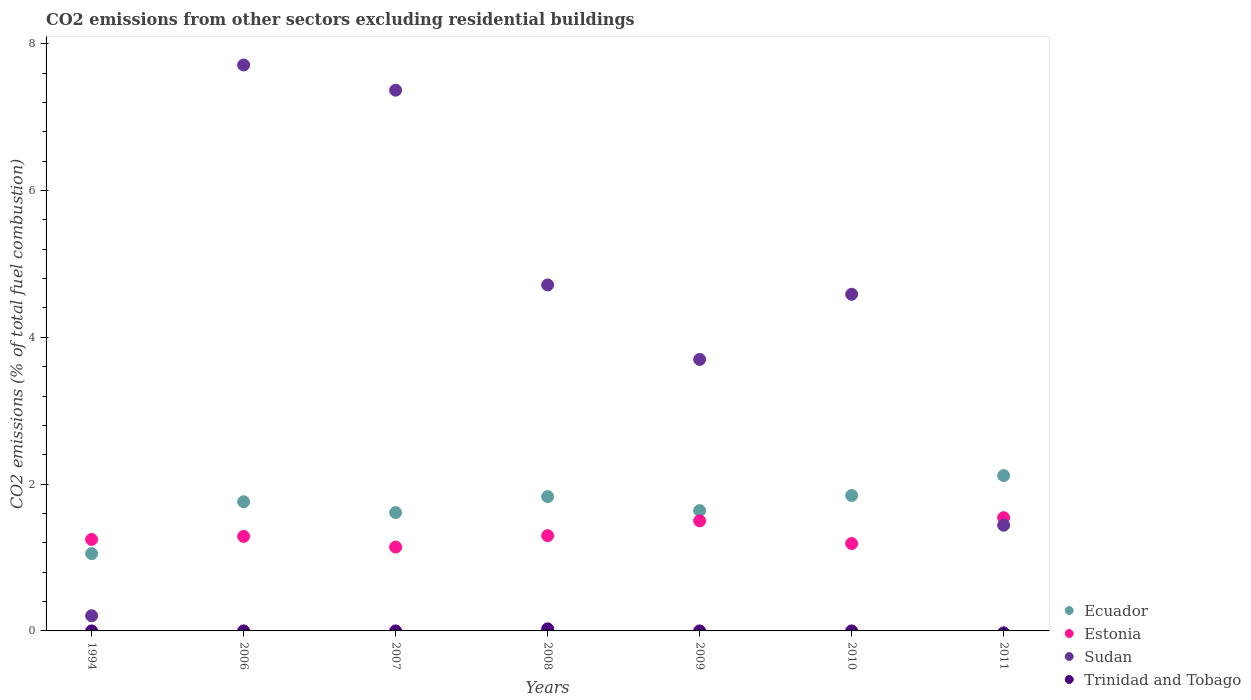How many different coloured dotlines are there?
Give a very brief answer. 4. What is the total CO2 emitted in Ecuador in 2011?
Ensure brevity in your answer.  2.12. Across all years, what is the maximum total CO2 emitted in Sudan?
Your response must be concise. 7.71. In which year was the total CO2 emitted in Estonia maximum?
Provide a succinct answer. 2011. What is the total total CO2 emitted in Ecuador in the graph?
Provide a short and direct response. 11.86. What is the difference between the total CO2 emitted in Estonia in 2007 and that in 2010?
Your answer should be compact. -0.05. What is the difference between the total CO2 emitted in Ecuador in 2006 and the total CO2 emitted in Sudan in 2011?
Your answer should be very brief. 0.32. What is the average total CO2 emitted in Trinidad and Tobago per year?
Your answer should be compact. 0. In the year 2009, what is the difference between the total CO2 emitted in Ecuador and total CO2 emitted in Estonia?
Provide a short and direct response. 0.14. In how many years, is the total CO2 emitted in Estonia greater than 5.2?
Make the answer very short. 0. What is the ratio of the total CO2 emitted in Sudan in 2006 to that in 2008?
Keep it short and to the point. 1.64. Is the difference between the total CO2 emitted in Ecuador in 1994 and 2008 greater than the difference between the total CO2 emitted in Estonia in 1994 and 2008?
Offer a terse response. No. What is the difference between the highest and the second highest total CO2 emitted in Estonia?
Ensure brevity in your answer.  0.04. What is the difference between the highest and the lowest total CO2 emitted in Trinidad and Tobago?
Ensure brevity in your answer.  0.03. Does the total CO2 emitted in Trinidad and Tobago monotonically increase over the years?
Give a very brief answer. No. Are the values on the major ticks of Y-axis written in scientific E-notation?
Ensure brevity in your answer.  No. Does the graph contain any zero values?
Keep it short and to the point. Yes. Does the graph contain grids?
Offer a terse response. No. How are the legend labels stacked?
Offer a terse response. Vertical. What is the title of the graph?
Give a very brief answer. CO2 emissions from other sectors excluding residential buildings. What is the label or title of the X-axis?
Your response must be concise. Years. What is the label or title of the Y-axis?
Provide a succinct answer. CO2 emissions (% of total fuel combustion). What is the CO2 emissions (% of total fuel combustion) of Ecuador in 1994?
Offer a terse response. 1.05. What is the CO2 emissions (% of total fuel combustion) in Estonia in 1994?
Provide a short and direct response. 1.25. What is the CO2 emissions (% of total fuel combustion) of Sudan in 1994?
Provide a short and direct response. 0.21. What is the CO2 emissions (% of total fuel combustion) in Trinidad and Tobago in 1994?
Give a very brief answer. 0. What is the CO2 emissions (% of total fuel combustion) in Ecuador in 2006?
Keep it short and to the point. 1.76. What is the CO2 emissions (% of total fuel combustion) in Estonia in 2006?
Offer a very short reply. 1.29. What is the CO2 emissions (% of total fuel combustion) in Sudan in 2006?
Provide a succinct answer. 7.71. What is the CO2 emissions (% of total fuel combustion) in Trinidad and Tobago in 2006?
Your answer should be very brief. 5.05750284541343e-17. What is the CO2 emissions (% of total fuel combustion) in Ecuador in 2007?
Your answer should be compact. 1.61. What is the CO2 emissions (% of total fuel combustion) in Estonia in 2007?
Ensure brevity in your answer.  1.14. What is the CO2 emissions (% of total fuel combustion) of Sudan in 2007?
Keep it short and to the point. 7.37. What is the CO2 emissions (% of total fuel combustion) of Trinidad and Tobago in 2007?
Keep it short and to the point. 4.75396951487204e-17. What is the CO2 emissions (% of total fuel combustion) of Ecuador in 2008?
Offer a very short reply. 1.83. What is the CO2 emissions (% of total fuel combustion) of Estonia in 2008?
Your answer should be very brief. 1.3. What is the CO2 emissions (% of total fuel combustion) in Sudan in 2008?
Provide a succinct answer. 4.71. What is the CO2 emissions (% of total fuel combustion) of Trinidad and Tobago in 2008?
Provide a short and direct response. 0.03. What is the CO2 emissions (% of total fuel combustion) of Ecuador in 2009?
Your answer should be very brief. 1.64. What is the CO2 emissions (% of total fuel combustion) of Estonia in 2009?
Make the answer very short. 1.5. What is the CO2 emissions (% of total fuel combustion) in Sudan in 2009?
Offer a very short reply. 3.7. What is the CO2 emissions (% of total fuel combustion) of Trinidad and Tobago in 2009?
Give a very brief answer. 0. What is the CO2 emissions (% of total fuel combustion) of Ecuador in 2010?
Offer a terse response. 1.85. What is the CO2 emissions (% of total fuel combustion) in Estonia in 2010?
Your answer should be compact. 1.19. What is the CO2 emissions (% of total fuel combustion) in Sudan in 2010?
Make the answer very short. 4.59. What is the CO2 emissions (% of total fuel combustion) in Ecuador in 2011?
Provide a short and direct response. 2.12. What is the CO2 emissions (% of total fuel combustion) of Estonia in 2011?
Your response must be concise. 1.54. What is the CO2 emissions (% of total fuel combustion) of Sudan in 2011?
Ensure brevity in your answer.  1.44. Across all years, what is the maximum CO2 emissions (% of total fuel combustion) of Ecuador?
Provide a short and direct response. 2.12. Across all years, what is the maximum CO2 emissions (% of total fuel combustion) in Estonia?
Your answer should be compact. 1.54. Across all years, what is the maximum CO2 emissions (% of total fuel combustion) of Sudan?
Make the answer very short. 7.71. Across all years, what is the maximum CO2 emissions (% of total fuel combustion) of Trinidad and Tobago?
Offer a very short reply. 0.03. Across all years, what is the minimum CO2 emissions (% of total fuel combustion) of Ecuador?
Your answer should be compact. 1.05. Across all years, what is the minimum CO2 emissions (% of total fuel combustion) in Estonia?
Your answer should be compact. 1.14. Across all years, what is the minimum CO2 emissions (% of total fuel combustion) of Sudan?
Ensure brevity in your answer.  0.21. Across all years, what is the minimum CO2 emissions (% of total fuel combustion) in Trinidad and Tobago?
Ensure brevity in your answer.  0. What is the total CO2 emissions (% of total fuel combustion) of Ecuador in the graph?
Offer a terse response. 11.86. What is the total CO2 emissions (% of total fuel combustion) of Estonia in the graph?
Your response must be concise. 9.21. What is the total CO2 emissions (% of total fuel combustion) in Sudan in the graph?
Provide a succinct answer. 29.72. What is the total CO2 emissions (% of total fuel combustion) in Trinidad and Tobago in the graph?
Offer a terse response. 0.03. What is the difference between the CO2 emissions (% of total fuel combustion) in Ecuador in 1994 and that in 2006?
Your answer should be compact. -0.71. What is the difference between the CO2 emissions (% of total fuel combustion) of Estonia in 1994 and that in 2006?
Keep it short and to the point. -0.04. What is the difference between the CO2 emissions (% of total fuel combustion) in Sudan in 1994 and that in 2006?
Offer a terse response. -7.5. What is the difference between the CO2 emissions (% of total fuel combustion) in Ecuador in 1994 and that in 2007?
Your response must be concise. -0.56. What is the difference between the CO2 emissions (% of total fuel combustion) of Estonia in 1994 and that in 2007?
Give a very brief answer. 0.1. What is the difference between the CO2 emissions (% of total fuel combustion) of Sudan in 1994 and that in 2007?
Your answer should be very brief. -7.16. What is the difference between the CO2 emissions (% of total fuel combustion) of Ecuador in 1994 and that in 2008?
Give a very brief answer. -0.78. What is the difference between the CO2 emissions (% of total fuel combustion) of Estonia in 1994 and that in 2008?
Provide a succinct answer. -0.05. What is the difference between the CO2 emissions (% of total fuel combustion) of Sudan in 1994 and that in 2008?
Give a very brief answer. -4.51. What is the difference between the CO2 emissions (% of total fuel combustion) of Ecuador in 1994 and that in 2009?
Ensure brevity in your answer.  -0.59. What is the difference between the CO2 emissions (% of total fuel combustion) of Estonia in 1994 and that in 2009?
Offer a terse response. -0.25. What is the difference between the CO2 emissions (% of total fuel combustion) of Sudan in 1994 and that in 2009?
Provide a short and direct response. -3.49. What is the difference between the CO2 emissions (% of total fuel combustion) of Ecuador in 1994 and that in 2010?
Make the answer very short. -0.79. What is the difference between the CO2 emissions (% of total fuel combustion) of Estonia in 1994 and that in 2010?
Provide a short and direct response. 0.06. What is the difference between the CO2 emissions (% of total fuel combustion) of Sudan in 1994 and that in 2010?
Make the answer very short. -4.38. What is the difference between the CO2 emissions (% of total fuel combustion) of Ecuador in 1994 and that in 2011?
Keep it short and to the point. -1.06. What is the difference between the CO2 emissions (% of total fuel combustion) in Estonia in 1994 and that in 2011?
Your answer should be compact. -0.3. What is the difference between the CO2 emissions (% of total fuel combustion) in Sudan in 1994 and that in 2011?
Provide a succinct answer. -1.23. What is the difference between the CO2 emissions (% of total fuel combustion) of Ecuador in 2006 and that in 2007?
Make the answer very short. 0.15. What is the difference between the CO2 emissions (% of total fuel combustion) in Estonia in 2006 and that in 2007?
Keep it short and to the point. 0.15. What is the difference between the CO2 emissions (% of total fuel combustion) of Sudan in 2006 and that in 2007?
Make the answer very short. 0.34. What is the difference between the CO2 emissions (% of total fuel combustion) of Ecuador in 2006 and that in 2008?
Offer a terse response. -0.07. What is the difference between the CO2 emissions (% of total fuel combustion) of Estonia in 2006 and that in 2008?
Your response must be concise. -0.01. What is the difference between the CO2 emissions (% of total fuel combustion) of Sudan in 2006 and that in 2008?
Your answer should be compact. 3. What is the difference between the CO2 emissions (% of total fuel combustion) of Trinidad and Tobago in 2006 and that in 2008?
Your answer should be very brief. -0.03. What is the difference between the CO2 emissions (% of total fuel combustion) of Ecuador in 2006 and that in 2009?
Keep it short and to the point. 0.12. What is the difference between the CO2 emissions (% of total fuel combustion) of Estonia in 2006 and that in 2009?
Your response must be concise. -0.21. What is the difference between the CO2 emissions (% of total fuel combustion) of Sudan in 2006 and that in 2009?
Provide a succinct answer. 4.01. What is the difference between the CO2 emissions (% of total fuel combustion) of Ecuador in 2006 and that in 2010?
Offer a terse response. -0.09. What is the difference between the CO2 emissions (% of total fuel combustion) in Estonia in 2006 and that in 2010?
Offer a terse response. 0.1. What is the difference between the CO2 emissions (% of total fuel combustion) in Sudan in 2006 and that in 2010?
Keep it short and to the point. 3.12. What is the difference between the CO2 emissions (% of total fuel combustion) of Ecuador in 2006 and that in 2011?
Keep it short and to the point. -0.36. What is the difference between the CO2 emissions (% of total fuel combustion) of Estonia in 2006 and that in 2011?
Make the answer very short. -0.26. What is the difference between the CO2 emissions (% of total fuel combustion) of Sudan in 2006 and that in 2011?
Offer a very short reply. 6.27. What is the difference between the CO2 emissions (% of total fuel combustion) in Ecuador in 2007 and that in 2008?
Your response must be concise. -0.22. What is the difference between the CO2 emissions (% of total fuel combustion) of Estonia in 2007 and that in 2008?
Your answer should be very brief. -0.16. What is the difference between the CO2 emissions (% of total fuel combustion) in Sudan in 2007 and that in 2008?
Ensure brevity in your answer.  2.65. What is the difference between the CO2 emissions (% of total fuel combustion) in Trinidad and Tobago in 2007 and that in 2008?
Offer a terse response. -0.03. What is the difference between the CO2 emissions (% of total fuel combustion) of Ecuador in 2007 and that in 2009?
Offer a very short reply. -0.03. What is the difference between the CO2 emissions (% of total fuel combustion) of Estonia in 2007 and that in 2009?
Your response must be concise. -0.36. What is the difference between the CO2 emissions (% of total fuel combustion) of Sudan in 2007 and that in 2009?
Ensure brevity in your answer.  3.67. What is the difference between the CO2 emissions (% of total fuel combustion) of Ecuador in 2007 and that in 2010?
Offer a terse response. -0.23. What is the difference between the CO2 emissions (% of total fuel combustion) in Estonia in 2007 and that in 2010?
Provide a succinct answer. -0.05. What is the difference between the CO2 emissions (% of total fuel combustion) of Sudan in 2007 and that in 2010?
Provide a succinct answer. 2.78. What is the difference between the CO2 emissions (% of total fuel combustion) in Ecuador in 2007 and that in 2011?
Make the answer very short. -0.5. What is the difference between the CO2 emissions (% of total fuel combustion) in Estonia in 2007 and that in 2011?
Your answer should be very brief. -0.4. What is the difference between the CO2 emissions (% of total fuel combustion) in Sudan in 2007 and that in 2011?
Keep it short and to the point. 5.93. What is the difference between the CO2 emissions (% of total fuel combustion) in Ecuador in 2008 and that in 2009?
Provide a short and direct response. 0.19. What is the difference between the CO2 emissions (% of total fuel combustion) in Estonia in 2008 and that in 2009?
Make the answer very short. -0.2. What is the difference between the CO2 emissions (% of total fuel combustion) of Sudan in 2008 and that in 2009?
Keep it short and to the point. 1.01. What is the difference between the CO2 emissions (% of total fuel combustion) of Ecuador in 2008 and that in 2010?
Provide a succinct answer. -0.02. What is the difference between the CO2 emissions (% of total fuel combustion) in Estonia in 2008 and that in 2010?
Your answer should be very brief. 0.11. What is the difference between the CO2 emissions (% of total fuel combustion) of Sudan in 2008 and that in 2010?
Your answer should be compact. 0.13. What is the difference between the CO2 emissions (% of total fuel combustion) of Ecuador in 2008 and that in 2011?
Offer a terse response. -0.29. What is the difference between the CO2 emissions (% of total fuel combustion) of Estonia in 2008 and that in 2011?
Give a very brief answer. -0.24. What is the difference between the CO2 emissions (% of total fuel combustion) of Sudan in 2008 and that in 2011?
Ensure brevity in your answer.  3.27. What is the difference between the CO2 emissions (% of total fuel combustion) of Ecuador in 2009 and that in 2010?
Give a very brief answer. -0.21. What is the difference between the CO2 emissions (% of total fuel combustion) in Estonia in 2009 and that in 2010?
Provide a succinct answer. 0.31. What is the difference between the CO2 emissions (% of total fuel combustion) in Sudan in 2009 and that in 2010?
Give a very brief answer. -0.89. What is the difference between the CO2 emissions (% of total fuel combustion) in Ecuador in 2009 and that in 2011?
Your answer should be compact. -0.48. What is the difference between the CO2 emissions (% of total fuel combustion) in Estonia in 2009 and that in 2011?
Make the answer very short. -0.04. What is the difference between the CO2 emissions (% of total fuel combustion) of Sudan in 2009 and that in 2011?
Provide a succinct answer. 2.26. What is the difference between the CO2 emissions (% of total fuel combustion) of Ecuador in 2010 and that in 2011?
Your answer should be very brief. -0.27. What is the difference between the CO2 emissions (% of total fuel combustion) in Estonia in 2010 and that in 2011?
Ensure brevity in your answer.  -0.35. What is the difference between the CO2 emissions (% of total fuel combustion) of Sudan in 2010 and that in 2011?
Provide a short and direct response. 3.15. What is the difference between the CO2 emissions (% of total fuel combustion) in Ecuador in 1994 and the CO2 emissions (% of total fuel combustion) in Estonia in 2006?
Your response must be concise. -0.23. What is the difference between the CO2 emissions (% of total fuel combustion) of Ecuador in 1994 and the CO2 emissions (% of total fuel combustion) of Sudan in 2006?
Provide a succinct answer. -6.66. What is the difference between the CO2 emissions (% of total fuel combustion) in Ecuador in 1994 and the CO2 emissions (% of total fuel combustion) in Trinidad and Tobago in 2006?
Your answer should be very brief. 1.05. What is the difference between the CO2 emissions (% of total fuel combustion) of Estonia in 1994 and the CO2 emissions (% of total fuel combustion) of Sudan in 2006?
Make the answer very short. -6.46. What is the difference between the CO2 emissions (% of total fuel combustion) in Estonia in 1994 and the CO2 emissions (% of total fuel combustion) in Trinidad and Tobago in 2006?
Ensure brevity in your answer.  1.25. What is the difference between the CO2 emissions (% of total fuel combustion) in Sudan in 1994 and the CO2 emissions (% of total fuel combustion) in Trinidad and Tobago in 2006?
Your answer should be very brief. 0.21. What is the difference between the CO2 emissions (% of total fuel combustion) of Ecuador in 1994 and the CO2 emissions (% of total fuel combustion) of Estonia in 2007?
Ensure brevity in your answer.  -0.09. What is the difference between the CO2 emissions (% of total fuel combustion) in Ecuador in 1994 and the CO2 emissions (% of total fuel combustion) in Sudan in 2007?
Keep it short and to the point. -6.31. What is the difference between the CO2 emissions (% of total fuel combustion) of Ecuador in 1994 and the CO2 emissions (% of total fuel combustion) of Trinidad and Tobago in 2007?
Ensure brevity in your answer.  1.05. What is the difference between the CO2 emissions (% of total fuel combustion) of Estonia in 1994 and the CO2 emissions (% of total fuel combustion) of Sudan in 2007?
Offer a terse response. -6.12. What is the difference between the CO2 emissions (% of total fuel combustion) in Estonia in 1994 and the CO2 emissions (% of total fuel combustion) in Trinidad and Tobago in 2007?
Your answer should be very brief. 1.25. What is the difference between the CO2 emissions (% of total fuel combustion) of Sudan in 1994 and the CO2 emissions (% of total fuel combustion) of Trinidad and Tobago in 2007?
Provide a short and direct response. 0.21. What is the difference between the CO2 emissions (% of total fuel combustion) of Ecuador in 1994 and the CO2 emissions (% of total fuel combustion) of Estonia in 2008?
Ensure brevity in your answer.  -0.24. What is the difference between the CO2 emissions (% of total fuel combustion) in Ecuador in 1994 and the CO2 emissions (% of total fuel combustion) in Sudan in 2008?
Your answer should be very brief. -3.66. What is the difference between the CO2 emissions (% of total fuel combustion) in Ecuador in 1994 and the CO2 emissions (% of total fuel combustion) in Trinidad and Tobago in 2008?
Ensure brevity in your answer.  1.03. What is the difference between the CO2 emissions (% of total fuel combustion) in Estonia in 1994 and the CO2 emissions (% of total fuel combustion) in Sudan in 2008?
Provide a short and direct response. -3.47. What is the difference between the CO2 emissions (% of total fuel combustion) of Estonia in 1994 and the CO2 emissions (% of total fuel combustion) of Trinidad and Tobago in 2008?
Make the answer very short. 1.22. What is the difference between the CO2 emissions (% of total fuel combustion) of Sudan in 1994 and the CO2 emissions (% of total fuel combustion) of Trinidad and Tobago in 2008?
Your answer should be very brief. 0.18. What is the difference between the CO2 emissions (% of total fuel combustion) of Ecuador in 1994 and the CO2 emissions (% of total fuel combustion) of Estonia in 2009?
Your answer should be very brief. -0.45. What is the difference between the CO2 emissions (% of total fuel combustion) of Ecuador in 1994 and the CO2 emissions (% of total fuel combustion) of Sudan in 2009?
Make the answer very short. -2.65. What is the difference between the CO2 emissions (% of total fuel combustion) in Estonia in 1994 and the CO2 emissions (% of total fuel combustion) in Sudan in 2009?
Give a very brief answer. -2.45. What is the difference between the CO2 emissions (% of total fuel combustion) of Ecuador in 1994 and the CO2 emissions (% of total fuel combustion) of Estonia in 2010?
Your answer should be very brief. -0.14. What is the difference between the CO2 emissions (% of total fuel combustion) of Ecuador in 1994 and the CO2 emissions (% of total fuel combustion) of Sudan in 2010?
Provide a short and direct response. -3.53. What is the difference between the CO2 emissions (% of total fuel combustion) of Estonia in 1994 and the CO2 emissions (% of total fuel combustion) of Sudan in 2010?
Offer a terse response. -3.34. What is the difference between the CO2 emissions (% of total fuel combustion) in Ecuador in 1994 and the CO2 emissions (% of total fuel combustion) in Estonia in 2011?
Offer a very short reply. -0.49. What is the difference between the CO2 emissions (% of total fuel combustion) of Ecuador in 1994 and the CO2 emissions (% of total fuel combustion) of Sudan in 2011?
Ensure brevity in your answer.  -0.39. What is the difference between the CO2 emissions (% of total fuel combustion) in Estonia in 1994 and the CO2 emissions (% of total fuel combustion) in Sudan in 2011?
Provide a succinct answer. -0.19. What is the difference between the CO2 emissions (% of total fuel combustion) in Ecuador in 2006 and the CO2 emissions (% of total fuel combustion) in Estonia in 2007?
Give a very brief answer. 0.62. What is the difference between the CO2 emissions (% of total fuel combustion) of Ecuador in 2006 and the CO2 emissions (% of total fuel combustion) of Sudan in 2007?
Ensure brevity in your answer.  -5.61. What is the difference between the CO2 emissions (% of total fuel combustion) in Ecuador in 2006 and the CO2 emissions (% of total fuel combustion) in Trinidad and Tobago in 2007?
Your response must be concise. 1.76. What is the difference between the CO2 emissions (% of total fuel combustion) in Estonia in 2006 and the CO2 emissions (% of total fuel combustion) in Sudan in 2007?
Your response must be concise. -6.08. What is the difference between the CO2 emissions (% of total fuel combustion) of Estonia in 2006 and the CO2 emissions (% of total fuel combustion) of Trinidad and Tobago in 2007?
Your answer should be very brief. 1.29. What is the difference between the CO2 emissions (% of total fuel combustion) in Sudan in 2006 and the CO2 emissions (% of total fuel combustion) in Trinidad and Tobago in 2007?
Your response must be concise. 7.71. What is the difference between the CO2 emissions (% of total fuel combustion) in Ecuador in 2006 and the CO2 emissions (% of total fuel combustion) in Estonia in 2008?
Ensure brevity in your answer.  0.46. What is the difference between the CO2 emissions (% of total fuel combustion) of Ecuador in 2006 and the CO2 emissions (% of total fuel combustion) of Sudan in 2008?
Offer a very short reply. -2.95. What is the difference between the CO2 emissions (% of total fuel combustion) of Ecuador in 2006 and the CO2 emissions (% of total fuel combustion) of Trinidad and Tobago in 2008?
Provide a succinct answer. 1.73. What is the difference between the CO2 emissions (% of total fuel combustion) in Estonia in 2006 and the CO2 emissions (% of total fuel combustion) in Sudan in 2008?
Provide a short and direct response. -3.43. What is the difference between the CO2 emissions (% of total fuel combustion) in Estonia in 2006 and the CO2 emissions (% of total fuel combustion) in Trinidad and Tobago in 2008?
Your response must be concise. 1.26. What is the difference between the CO2 emissions (% of total fuel combustion) in Sudan in 2006 and the CO2 emissions (% of total fuel combustion) in Trinidad and Tobago in 2008?
Your response must be concise. 7.68. What is the difference between the CO2 emissions (% of total fuel combustion) in Ecuador in 2006 and the CO2 emissions (% of total fuel combustion) in Estonia in 2009?
Provide a succinct answer. 0.26. What is the difference between the CO2 emissions (% of total fuel combustion) of Ecuador in 2006 and the CO2 emissions (% of total fuel combustion) of Sudan in 2009?
Keep it short and to the point. -1.94. What is the difference between the CO2 emissions (% of total fuel combustion) of Estonia in 2006 and the CO2 emissions (% of total fuel combustion) of Sudan in 2009?
Your response must be concise. -2.41. What is the difference between the CO2 emissions (% of total fuel combustion) in Ecuador in 2006 and the CO2 emissions (% of total fuel combustion) in Estonia in 2010?
Make the answer very short. 0.57. What is the difference between the CO2 emissions (% of total fuel combustion) of Ecuador in 2006 and the CO2 emissions (% of total fuel combustion) of Sudan in 2010?
Your answer should be compact. -2.83. What is the difference between the CO2 emissions (% of total fuel combustion) in Estonia in 2006 and the CO2 emissions (% of total fuel combustion) in Sudan in 2010?
Provide a succinct answer. -3.3. What is the difference between the CO2 emissions (% of total fuel combustion) of Ecuador in 2006 and the CO2 emissions (% of total fuel combustion) of Estonia in 2011?
Your answer should be very brief. 0.22. What is the difference between the CO2 emissions (% of total fuel combustion) of Ecuador in 2006 and the CO2 emissions (% of total fuel combustion) of Sudan in 2011?
Your answer should be very brief. 0.32. What is the difference between the CO2 emissions (% of total fuel combustion) of Estonia in 2006 and the CO2 emissions (% of total fuel combustion) of Sudan in 2011?
Offer a terse response. -0.15. What is the difference between the CO2 emissions (% of total fuel combustion) in Ecuador in 2007 and the CO2 emissions (% of total fuel combustion) in Estonia in 2008?
Provide a short and direct response. 0.31. What is the difference between the CO2 emissions (% of total fuel combustion) in Ecuador in 2007 and the CO2 emissions (% of total fuel combustion) in Sudan in 2008?
Give a very brief answer. -3.1. What is the difference between the CO2 emissions (% of total fuel combustion) of Ecuador in 2007 and the CO2 emissions (% of total fuel combustion) of Trinidad and Tobago in 2008?
Ensure brevity in your answer.  1.58. What is the difference between the CO2 emissions (% of total fuel combustion) in Estonia in 2007 and the CO2 emissions (% of total fuel combustion) in Sudan in 2008?
Give a very brief answer. -3.57. What is the difference between the CO2 emissions (% of total fuel combustion) in Estonia in 2007 and the CO2 emissions (% of total fuel combustion) in Trinidad and Tobago in 2008?
Give a very brief answer. 1.11. What is the difference between the CO2 emissions (% of total fuel combustion) of Sudan in 2007 and the CO2 emissions (% of total fuel combustion) of Trinidad and Tobago in 2008?
Ensure brevity in your answer.  7.34. What is the difference between the CO2 emissions (% of total fuel combustion) in Ecuador in 2007 and the CO2 emissions (% of total fuel combustion) in Estonia in 2009?
Ensure brevity in your answer.  0.11. What is the difference between the CO2 emissions (% of total fuel combustion) in Ecuador in 2007 and the CO2 emissions (% of total fuel combustion) in Sudan in 2009?
Give a very brief answer. -2.09. What is the difference between the CO2 emissions (% of total fuel combustion) in Estonia in 2007 and the CO2 emissions (% of total fuel combustion) in Sudan in 2009?
Keep it short and to the point. -2.56. What is the difference between the CO2 emissions (% of total fuel combustion) of Ecuador in 2007 and the CO2 emissions (% of total fuel combustion) of Estonia in 2010?
Give a very brief answer. 0.42. What is the difference between the CO2 emissions (% of total fuel combustion) of Ecuador in 2007 and the CO2 emissions (% of total fuel combustion) of Sudan in 2010?
Your answer should be compact. -2.97. What is the difference between the CO2 emissions (% of total fuel combustion) in Estonia in 2007 and the CO2 emissions (% of total fuel combustion) in Sudan in 2010?
Your response must be concise. -3.44. What is the difference between the CO2 emissions (% of total fuel combustion) in Ecuador in 2007 and the CO2 emissions (% of total fuel combustion) in Estonia in 2011?
Your answer should be very brief. 0.07. What is the difference between the CO2 emissions (% of total fuel combustion) in Ecuador in 2007 and the CO2 emissions (% of total fuel combustion) in Sudan in 2011?
Keep it short and to the point. 0.17. What is the difference between the CO2 emissions (% of total fuel combustion) of Estonia in 2007 and the CO2 emissions (% of total fuel combustion) of Sudan in 2011?
Ensure brevity in your answer.  -0.3. What is the difference between the CO2 emissions (% of total fuel combustion) of Ecuador in 2008 and the CO2 emissions (% of total fuel combustion) of Estonia in 2009?
Provide a short and direct response. 0.33. What is the difference between the CO2 emissions (% of total fuel combustion) in Ecuador in 2008 and the CO2 emissions (% of total fuel combustion) in Sudan in 2009?
Keep it short and to the point. -1.87. What is the difference between the CO2 emissions (% of total fuel combustion) of Estonia in 2008 and the CO2 emissions (% of total fuel combustion) of Sudan in 2009?
Ensure brevity in your answer.  -2.4. What is the difference between the CO2 emissions (% of total fuel combustion) of Ecuador in 2008 and the CO2 emissions (% of total fuel combustion) of Estonia in 2010?
Your answer should be compact. 0.64. What is the difference between the CO2 emissions (% of total fuel combustion) in Ecuador in 2008 and the CO2 emissions (% of total fuel combustion) in Sudan in 2010?
Offer a very short reply. -2.76. What is the difference between the CO2 emissions (% of total fuel combustion) in Estonia in 2008 and the CO2 emissions (% of total fuel combustion) in Sudan in 2010?
Your answer should be compact. -3.29. What is the difference between the CO2 emissions (% of total fuel combustion) in Ecuador in 2008 and the CO2 emissions (% of total fuel combustion) in Estonia in 2011?
Your answer should be very brief. 0.29. What is the difference between the CO2 emissions (% of total fuel combustion) of Ecuador in 2008 and the CO2 emissions (% of total fuel combustion) of Sudan in 2011?
Offer a terse response. 0.39. What is the difference between the CO2 emissions (% of total fuel combustion) in Estonia in 2008 and the CO2 emissions (% of total fuel combustion) in Sudan in 2011?
Make the answer very short. -0.14. What is the difference between the CO2 emissions (% of total fuel combustion) of Ecuador in 2009 and the CO2 emissions (% of total fuel combustion) of Estonia in 2010?
Your answer should be very brief. 0.45. What is the difference between the CO2 emissions (% of total fuel combustion) in Ecuador in 2009 and the CO2 emissions (% of total fuel combustion) in Sudan in 2010?
Offer a terse response. -2.95. What is the difference between the CO2 emissions (% of total fuel combustion) of Estonia in 2009 and the CO2 emissions (% of total fuel combustion) of Sudan in 2010?
Offer a terse response. -3.09. What is the difference between the CO2 emissions (% of total fuel combustion) of Ecuador in 2009 and the CO2 emissions (% of total fuel combustion) of Estonia in 2011?
Your response must be concise. 0.1. What is the difference between the CO2 emissions (% of total fuel combustion) in Ecuador in 2009 and the CO2 emissions (% of total fuel combustion) in Sudan in 2011?
Your response must be concise. 0.2. What is the difference between the CO2 emissions (% of total fuel combustion) of Estonia in 2009 and the CO2 emissions (% of total fuel combustion) of Sudan in 2011?
Provide a succinct answer. 0.06. What is the difference between the CO2 emissions (% of total fuel combustion) in Ecuador in 2010 and the CO2 emissions (% of total fuel combustion) in Estonia in 2011?
Your response must be concise. 0.3. What is the difference between the CO2 emissions (% of total fuel combustion) of Ecuador in 2010 and the CO2 emissions (% of total fuel combustion) of Sudan in 2011?
Your answer should be compact. 0.41. What is the difference between the CO2 emissions (% of total fuel combustion) in Estonia in 2010 and the CO2 emissions (% of total fuel combustion) in Sudan in 2011?
Provide a short and direct response. -0.25. What is the average CO2 emissions (% of total fuel combustion) of Ecuador per year?
Make the answer very short. 1.69. What is the average CO2 emissions (% of total fuel combustion) in Estonia per year?
Your response must be concise. 1.32. What is the average CO2 emissions (% of total fuel combustion) of Sudan per year?
Provide a succinct answer. 4.25. What is the average CO2 emissions (% of total fuel combustion) of Trinidad and Tobago per year?
Make the answer very short. 0. In the year 1994, what is the difference between the CO2 emissions (% of total fuel combustion) in Ecuador and CO2 emissions (% of total fuel combustion) in Estonia?
Make the answer very short. -0.19. In the year 1994, what is the difference between the CO2 emissions (% of total fuel combustion) of Ecuador and CO2 emissions (% of total fuel combustion) of Sudan?
Offer a very short reply. 0.85. In the year 1994, what is the difference between the CO2 emissions (% of total fuel combustion) of Estonia and CO2 emissions (% of total fuel combustion) of Sudan?
Your answer should be very brief. 1.04. In the year 2006, what is the difference between the CO2 emissions (% of total fuel combustion) in Ecuador and CO2 emissions (% of total fuel combustion) in Estonia?
Your answer should be very brief. 0.47. In the year 2006, what is the difference between the CO2 emissions (% of total fuel combustion) in Ecuador and CO2 emissions (% of total fuel combustion) in Sudan?
Provide a succinct answer. -5.95. In the year 2006, what is the difference between the CO2 emissions (% of total fuel combustion) in Ecuador and CO2 emissions (% of total fuel combustion) in Trinidad and Tobago?
Your answer should be very brief. 1.76. In the year 2006, what is the difference between the CO2 emissions (% of total fuel combustion) in Estonia and CO2 emissions (% of total fuel combustion) in Sudan?
Your answer should be very brief. -6.42. In the year 2006, what is the difference between the CO2 emissions (% of total fuel combustion) in Estonia and CO2 emissions (% of total fuel combustion) in Trinidad and Tobago?
Your response must be concise. 1.29. In the year 2006, what is the difference between the CO2 emissions (% of total fuel combustion) of Sudan and CO2 emissions (% of total fuel combustion) of Trinidad and Tobago?
Keep it short and to the point. 7.71. In the year 2007, what is the difference between the CO2 emissions (% of total fuel combustion) of Ecuador and CO2 emissions (% of total fuel combustion) of Estonia?
Your answer should be compact. 0.47. In the year 2007, what is the difference between the CO2 emissions (% of total fuel combustion) in Ecuador and CO2 emissions (% of total fuel combustion) in Sudan?
Provide a succinct answer. -5.75. In the year 2007, what is the difference between the CO2 emissions (% of total fuel combustion) of Ecuador and CO2 emissions (% of total fuel combustion) of Trinidad and Tobago?
Make the answer very short. 1.61. In the year 2007, what is the difference between the CO2 emissions (% of total fuel combustion) of Estonia and CO2 emissions (% of total fuel combustion) of Sudan?
Your answer should be compact. -6.22. In the year 2007, what is the difference between the CO2 emissions (% of total fuel combustion) in Estonia and CO2 emissions (% of total fuel combustion) in Trinidad and Tobago?
Make the answer very short. 1.14. In the year 2007, what is the difference between the CO2 emissions (% of total fuel combustion) in Sudan and CO2 emissions (% of total fuel combustion) in Trinidad and Tobago?
Your answer should be compact. 7.37. In the year 2008, what is the difference between the CO2 emissions (% of total fuel combustion) in Ecuador and CO2 emissions (% of total fuel combustion) in Estonia?
Offer a very short reply. 0.53. In the year 2008, what is the difference between the CO2 emissions (% of total fuel combustion) in Ecuador and CO2 emissions (% of total fuel combustion) in Sudan?
Your response must be concise. -2.88. In the year 2008, what is the difference between the CO2 emissions (% of total fuel combustion) in Ecuador and CO2 emissions (% of total fuel combustion) in Trinidad and Tobago?
Ensure brevity in your answer.  1.8. In the year 2008, what is the difference between the CO2 emissions (% of total fuel combustion) of Estonia and CO2 emissions (% of total fuel combustion) of Sudan?
Keep it short and to the point. -3.42. In the year 2008, what is the difference between the CO2 emissions (% of total fuel combustion) of Estonia and CO2 emissions (% of total fuel combustion) of Trinidad and Tobago?
Give a very brief answer. 1.27. In the year 2008, what is the difference between the CO2 emissions (% of total fuel combustion) of Sudan and CO2 emissions (% of total fuel combustion) of Trinidad and Tobago?
Provide a short and direct response. 4.69. In the year 2009, what is the difference between the CO2 emissions (% of total fuel combustion) in Ecuador and CO2 emissions (% of total fuel combustion) in Estonia?
Your answer should be very brief. 0.14. In the year 2009, what is the difference between the CO2 emissions (% of total fuel combustion) in Ecuador and CO2 emissions (% of total fuel combustion) in Sudan?
Make the answer very short. -2.06. In the year 2009, what is the difference between the CO2 emissions (% of total fuel combustion) in Estonia and CO2 emissions (% of total fuel combustion) in Sudan?
Keep it short and to the point. -2.2. In the year 2010, what is the difference between the CO2 emissions (% of total fuel combustion) of Ecuador and CO2 emissions (% of total fuel combustion) of Estonia?
Your answer should be compact. 0.66. In the year 2010, what is the difference between the CO2 emissions (% of total fuel combustion) in Ecuador and CO2 emissions (% of total fuel combustion) in Sudan?
Your answer should be compact. -2.74. In the year 2010, what is the difference between the CO2 emissions (% of total fuel combustion) of Estonia and CO2 emissions (% of total fuel combustion) of Sudan?
Provide a succinct answer. -3.4. In the year 2011, what is the difference between the CO2 emissions (% of total fuel combustion) of Ecuador and CO2 emissions (% of total fuel combustion) of Estonia?
Offer a terse response. 0.57. In the year 2011, what is the difference between the CO2 emissions (% of total fuel combustion) of Ecuador and CO2 emissions (% of total fuel combustion) of Sudan?
Your answer should be very brief. 0.68. In the year 2011, what is the difference between the CO2 emissions (% of total fuel combustion) in Estonia and CO2 emissions (% of total fuel combustion) in Sudan?
Provide a succinct answer. 0.1. What is the ratio of the CO2 emissions (% of total fuel combustion) of Ecuador in 1994 to that in 2006?
Give a very brief answer. 0.6. What is the ratio of the CO2 emissions (% of total fuel combustion) of Estonia in 1994 to that in 2006?
Provide a succinct answer. 0.97. What is the ratio of the CO2 emissions (% of total fuel combustion) in Sudan in 1994 to that in 2006?
Give a very brief answer. 0.03. What is the ratio of the CO2 emissions (% of total fuel combustion) of Ecuador in 1994 to that in 2007?
Offer a very short reply. 0.65. What is the ratio of the CO2 emissions (% of total fuel combustion) in Estonia in 1994 to that in 2007?
Give a very brief answer. 1.09. What is the ratio of the CO2 emissions (% of total fuel combustion) of Sudan in 1994 to that in 2007?
Ensure brevity in your answer.  0.03. What is the ratio of the CO2 emissions (% of total fuel combustion) of Ecuador in 1994 to that in 2008?
Offer a terse response. 0.58. What is the ratio of the CO2 emissions (% of total fuel combustion) of Estonia in 1994 to that in 2008?
Your answer should be compact. 0.96. What is the ratio of the CO2 emissions (% of total fuel combustion) of Sudan in 1994 to that in 2008?
Your answer should be compact. 0.04. What is the ratio of the CO2 emissions (% of total fuel combustion) of Ecuador in 1994 to that in 2009?
Give a very brief answer. 0.64. What is the ratio of the CO2 emissions (% of total fuel combustion) in Estonia in 1994 to that in 2009?
Your answer should be compact. 0.83. What is the ratio of the CO2 emissions (% of total fuel combustion) of Sudan in 1994 to that in 2009?
Provide a succinct answer. 0.06. What is the ratio of the CO2 emissions (% of total fuel combustion) of Ecuador in 1994 to that in 2010?
Your answer should be compact. 0.57. What is the ratio of the CO2 emissions (% of total fuel combustion) in Estonia in 1994 to that in 2010?
Give a very brief answer. 1.05. What is the ratio of the CO2 emissions (% of total fuel combustion) in Sudan in 1994 to that in 2010?
Give a very brief answer. 0.04. What is the ratio of the CO2 emissions (% of total fuel combustion) of Ecuador in 1994 to that in 2011?
Keep it short and to the point. 0.5. What is the ratio of the CO2 emissions (% of total fuel combustion) of Estonia in 1994 to that in 2011?
Your answer should be very brief. 0.81. What is the ratio of the CO2 emissions (% of total fuel combustion) in Sudan in 1994 to that in 2011?
Ensure brevity in your answer.  0.14. What is the ratio of the CO2 emissions (% of total fuel combustion) of Ecuador in 2006 to that in 2007?
Provide a short and direct response. 1.09. What is the ratio of the CO2 emissions (% of total fuel combustion) of Estonia in 2006 to that in 2007?
Give a very brief answer. 1.13. What is the ratio of the CO2 emissions (% of total fuel combustion) of Sudan in 2006 to that in 2007?
Your response must be concise. 1.05. What is the ratio of the CO2 emissions (% of total fuel combustion) in Trinidad and Tobago in 2006 to that in 2007?
Make the answer very short. 1.06. What is the ratio of the CO2 emissions (% of total fuel combustion) of Ecuador in 2006 to that in 2008?
Give a very brief answer. 0.96. What is the ratio of the CO2 emissions (% of total fuel combustion) of Estonia in 2006 to that in 2008?
Offer a very short reply. 0.99. What is the ratio of the CO2 emissions (% of total fuel combustion) in Sudan in 2006 to that in 2008?
Provide a succinct answer. 1.64. What is the ratio of the CO2 emissions (% of total fuel combustion) in Trinidad and Tobago in 2006 to that in 2008?
Your answer should be compact. 0. What is the ratio of the CO2 emissions (% of total fuel combustion) in Ecuador in 2006 to that in 2009?
Offer a terse response. 1.07. What is the ratio of the CO2 emissions (% of total fuel combustion) of Estonia in 2006 to that in 2009?
Provide a succinct answer. 0.86. What is the ratio of the CO2 emissions (% of total fuel combustion) in Sudan in 2006 to that in 2009?
Your answer should be compact. 2.08. What is the ratio of the CO2 emissions (% of total fuel combustion) of Ecuador in 2006 to that in 2010?
Offer a very short reply. 0.95. What is the ratio of the CO2 emissions (% of total fuel combustion) of Estonia in 2006 to that in 2010?
Provide a succinct answer. 1.08. What is the ratio of the CO2 emissions (% of total fuel combustion) of Sudan in 2006 to that in 2010?
Give a very brief answer. 1.68. What is the ratio of the CO2 emissions (% of total fuel combustion) in Ecuador in 2006 to that in 2011?
Your response must be concise. 0.83. What is the ratio of the CO2 emissions (% of total fuel combustion) of Estonia in 2006 to that in 2011?
Ensure brevity in your answer.  0.83. What is the ratio of the CO2 emissions (% of total fuel combustion) of Sudan in 2006 to that in 2011?
Your response must be concise. 5.35. What is the ratio of the CO2 emissions (% of total fuel combustion) of Ecuador in 2007 to that in 2008?
Offer a very short reply. 0.88. What is the ratio of the CO2 emissions (% of total fuel combustion) in Estonia in 2007 to that in 2008?
Your answer should be very brief. 0.88. What is the ratio of the CO2 emissions (% of total fuel combustion) of Sudan in 2007 to that in 2008?
Your answer should be compact. 1.56. What is the ratio of the CO2 emissions (% of total fuel combustion) in Ecuador in 2007 to that in 2009?
Offer a terse response. 0.98. What is the ratio of the CO2 emissions (% of total fuel combustion) of Estonia in 2007 to that in 2009?
Offer a very short reply. 0.76. What is the ratio of the CO2 emissions (% of total fuel combustion) in Sudan in 2007 to that in 2009?
Give a very brief answer. 1.99. What is the ratio of the CO2 emissions (% of total fuel combustion) of Ecuador in 2007 to that in 2010?
Offer a terse response. 0.87. What is the ratio of the CO2 emissions (% of total fuel combustion) in Estonia in 2007 to that in 2010?
Your response must be concise. 0.96. What is the ratio of the CO2 emissions (% of total fuel combustion) in Sudan in 2007 to that in 2010?
Offer a very short reply. 1.61. What is the ratio of the CO2 emissions (% of total fuel combustion) in Ecuador in 2007 to that in 2011?
Offer a very short reply. 0.76. What is the ratio of the CO2 emissions (% of total fuel combustion) of Estonia in 2007 to that in 2011?
Ensure brevity in your answer.  0.74. What is the ratio of the CO2 emissions (% of total fuel combustion) of Sudan in 2007 to that in 2011?
Offer a very short reply. 5.11. What is the ratio of the CO2 emissions (% of total fuel combustion) of Ecuador in 2008 to that in 2009?
Offer a terse response. 1.12. What is the ratio of the CO2 emissions (% of total fuel combustion) of Estonia in 2008 to that in 2009?
Offer a very short reply. 0.87. What is the ratio of the CO2 emissions (% of total fuel combustion) in Sudan in 2008 to that in 2009?
Offer a very short reply. 1.27. What is the ratio of the CO2 emissions (% of total fuel combustion) of Estonia in 2008 to that in 2010?
Your response must be concise. 1.09. What is the ratio of the CO2 emissions (% of total fuel combustion) in Sudan in 2008 to that in 2010?
Your response must be concise. 1.03. What is the ratio of the CO2 emissions (% of total fuel combustion) in Ecuador in 2008 to that in 2011?
Keep it short and to the point. 0.86. What is the ratio of the CO2 emissions (% of total fuel combustion) in Estonia in 2008 to that in 2011?
Provide a short and direct response. 0.84. What is the ratio of the CO2 emissions (% of total fuel combustion) in Sudan in 2008 to that in 2011?
Offer a very short reply. 3.27. What is the ratio of the CO2 emissions (% of total fuel combustion) in Ecuador in 2009 to that in 2010?
Your answer should be compact. 0.89. What is the ratio of the CO2 emissions (% of total fuel combustion) of Estonia in 2009 to that in 2010?
Ensure brevity in your answer.  1.26. What is the ratio of the CO2 emissions (% of total fuel combustion) of Sudan in 2009 to that in 2010?
Your response must be concise. 0.81. What is the ratio of the CO2 emissions (% of total fuel combustion) in Ecuador in 2009 to that in 2011?
Your answer should be compact. 0.77. What is the ratio of the CO2 emissions (% of total fuel combustion) of Sudan in 2009 to that in 2011?
Your answer should be compact. 2.57. What is the ratio of the CO2 emissions (% of total fuel combustion) of Ecuador in 2010 to that in 2011?
Offer a terse response. 0.87. What is the ratio of the CO2 emissions (% of total fuel combustion) of Estonia in 2010 to that in 2011?
Offer a very short reply. 0.77. What is the ratio of the CO2 emissions (% of total fuel combustion) in Sudan in 2010 to that in 2011?
Provide a short and direct response. 3.18. What is the difference between the highest and the second highest CO2 emissions (% of total fuel combustion) in Ecuador?
Provide a short and direct response. 0.27. What is the difference between the highest and the second highest CO2 emissions (% of total fuel combustion) in Estonia?
Offer a very short reply. 0.04. What is the difference between the highest and the second highest CO2 emissions (% of total fuel combustion) in Sudan?
Make the answer very short. 0.34. What is the difference between the highest and the second highest CO2 emissions (% of total fuel combustion) in Trinidad and Tobago?
Make the answer very short. 0.03. What is the difference between the highest and the lowest CO2 emissions (% of total fuel combustion) in Ecuador?
Provide a succinct answer. 1.06. What is the difference between the highest and the lowest CO2 emissions (% of total fuel combustion) of Estonia?
Your answer should be very brief. 0.4. What is the difference between the highest and the lowest CO2 emissions (% of total fuel combustion) in Sudan?
Your answer should be very brief. 7.5. What is the difference between the highest and the lowest CO2 emissions (% of total fuel combustion) of Trinidad and Tobago?
Ensure brevity in your answer.  0.03. 